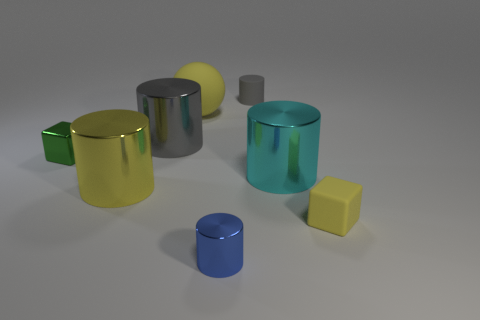Does the small green thing have the same material as the sphere?
Provide a succinct answer. No. Does the small rubber cube have the same color as the matte ball?
Keep it short and to the point. Yes. There is a yellow cylinder that is the same material as the blue cylinder; what size is it?
Keep it short and to the point. Large. What is the color of the metallic cylinder that is both on the right side of the matte sphere and to the left of the cyan thing?
Ensure brevity in your answer.  Blue. How many other cyan objects have the same size as the cyan thing?
Keep it short and to the point. 0. The metal object that is the same color as the sphere is what size?
Your answer should be very brief. Large. There is a metal thing that is both behind the yellow matte cube and in front of the large cyan object; how big is it?
Your answer should be very brief. Large. There is a large metal cylinder to the right of the tiny cylinder behind the matte cube; how many tiny green shiny cubes are behind it?
Offer a terse response. 1. Are there any shiny objects of the same color as the rubber cylinder?
Your answer should be compact. Yes. The other block that is the same size as the yellow rubber block is what color?
Ensure brevity in your answer.  Green. 